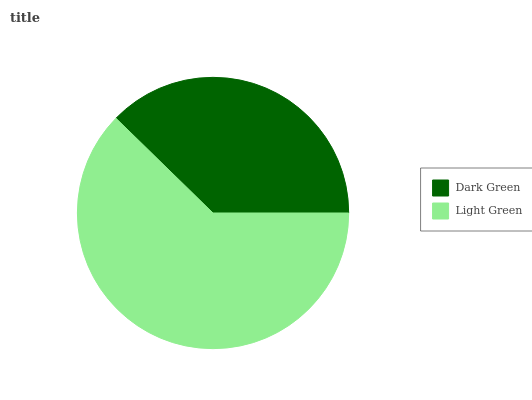Is Dark Green the minimum?
Answer yes or no. Yes. Is Light Green the maximum?
Answer yes or no. Yes. Is Light Green the minimum?
Answer yes or no. No. Is Light Green greater than Dark Green?
Answer yes or no. Yes. Is Dark Green less than Light Green?
Answer yes or no. Yes. Is Dark Green greater than Light Green?
Answer yes or no. No. Is Light Green less than Dark Green?
Answer yes or no. No. Is Light Green the high median?
Answer yes or no. Yes. Is Dark Green the low median?
Answer yes or no. Yes. Is Dark Green the high median?
Answer yes or no. No. Is Light Green the low median?
Answer yes or no. No. 